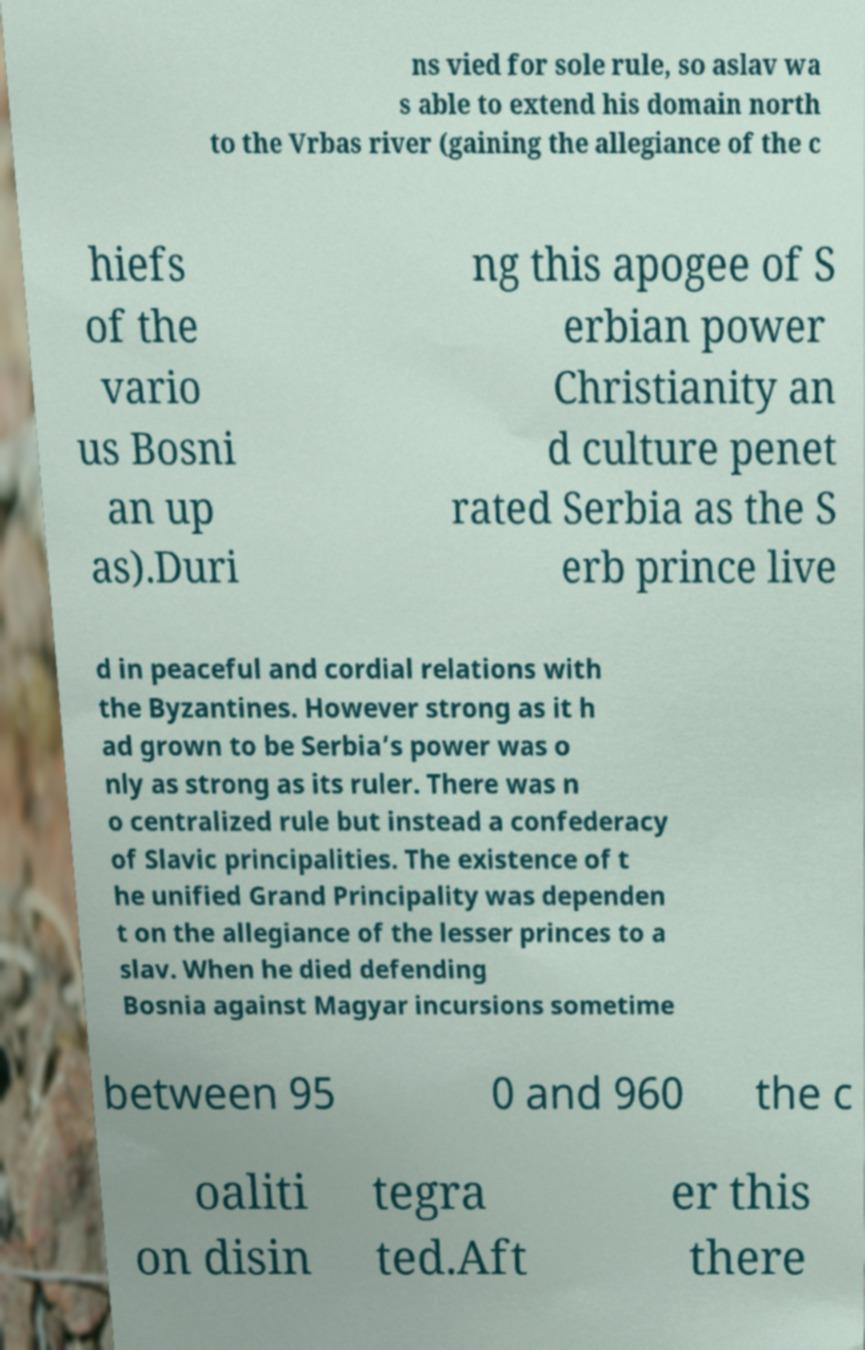Can you read and provide the text displayed in the image?This photo seems to have some interesting text. Can you extract and type it out for me? ns vied for sole rule, so aslav wa s able to extend his domain north to the Vrbas river (gaining the allegiance of the c hiefs of the vario us Bosni an up as).Duri ng this apogee of S erbian power Christianity an d culture penet rated Serbia as the S erb prince live d in peaceful and cordial relations with the Byzantines. However strong as it h ad grown to be Serbia’s power was o nly as strong as its ruler. There was n o centralized rule but instead a confederacy of Slavic principalities. The existence of t he unified Grand Principality was dependen t on the allegiance of the lesser princes to a slav. When he died defending Bosnia against Magyar incursions sometime between 95 0 and 960 the c oaliti on disin tegra ted.Aft er this there 